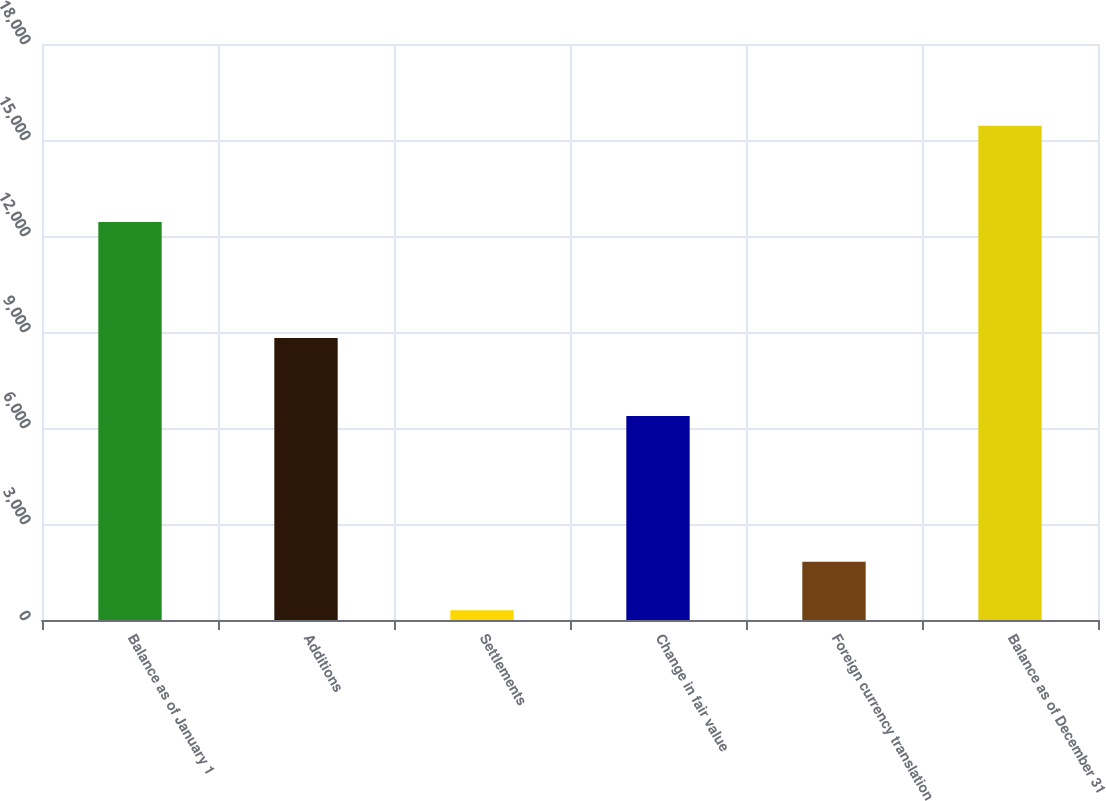Convert chart. <chart><loc_0><loc_0><loc_500><loc_500><bar_chart><fcel>Balance as of January 1<fcel>Additions<fcel>Settlements<fcel>Change in fair value<fcel>Foreign currency translation<fcel>Balance as of December 31<nl><fcel>12436<fcel>8811<fcel>306<fcel>6372<fcel>1819.8<fcel>15444<nl></chart> 